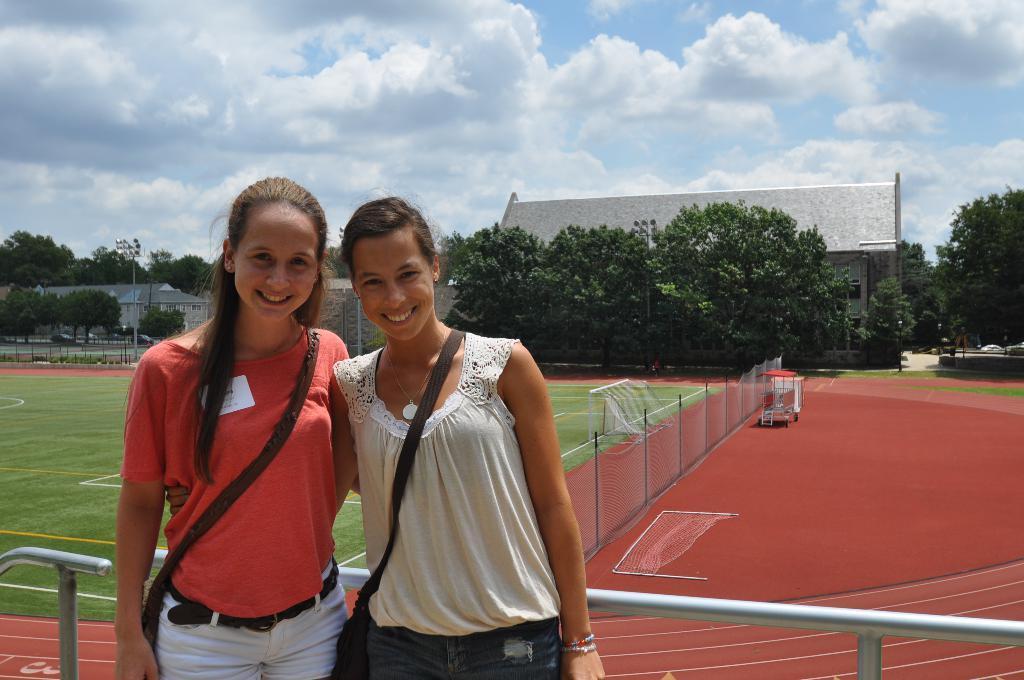Can you describe this image briefly? In this image I can see two persons standing, the person at right is wearing white shirt and black bag, the person at left is wearing red shirt and white pant. Background I can see the facing, trees in green color, a building in white color and the sky is in white and blue color. 